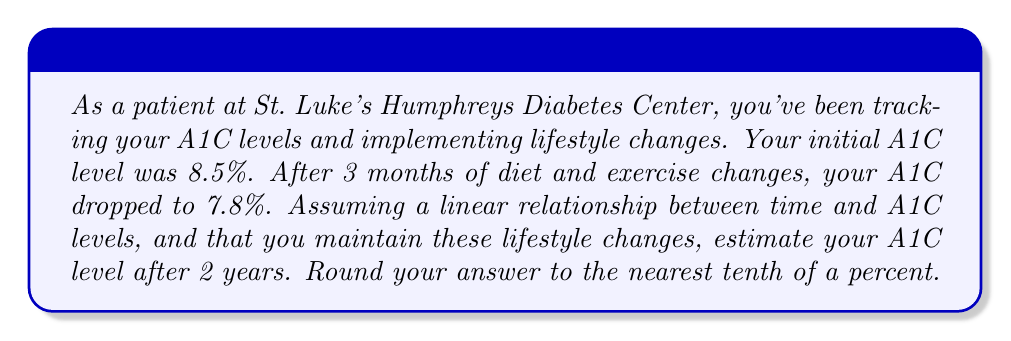Give your solution to this math problem. To solve this problem, we'll use a linear equation to model the relationship between time and A1C levels:

1) First, let's define our variables:
   $x$ = time in months
   $y$ = A1C level

2) We can form a linear equation in the form $y = mx + b$, where $m$ is the slope and $b$ is the y-intercept.

3) Calculate the slope:
   $m = \frac{\text{change in y}}{\text{change in x}} = \frac{7.8 - 8.5}{3 - 0} = \frac{-0.7}{3} = -0.233333$ per month

4) Find the y-intercept (initial A1C level):
   $b = 8.5$

5) Our linear equation is:
   $y = -0.233333x + 8.5$

6) To find the A1C level after 2 years, we substitute $x = 24$ (months):
   $y = -0.233333(24) + 8.5$
   $y = -5.6 + 8.5$
   $y = 2.9$

7) Rounding to the nearest tenth:
   $y \approx 2.9\%$

However, it's important to note that in reality, A1C levels don't typically drop below 4% in healthy individuals. This linear model doesn't account for the body's natural limitations. A more realistic estimate would be that the A1C level approaches a healthy range of 4-5.6% and stabilizes there.
Answer: 2.9% (with the caveat that this is a mathematical projection, and in reality, A1C levels would likely stabilize around 4-5.6% for a healthy individual) 